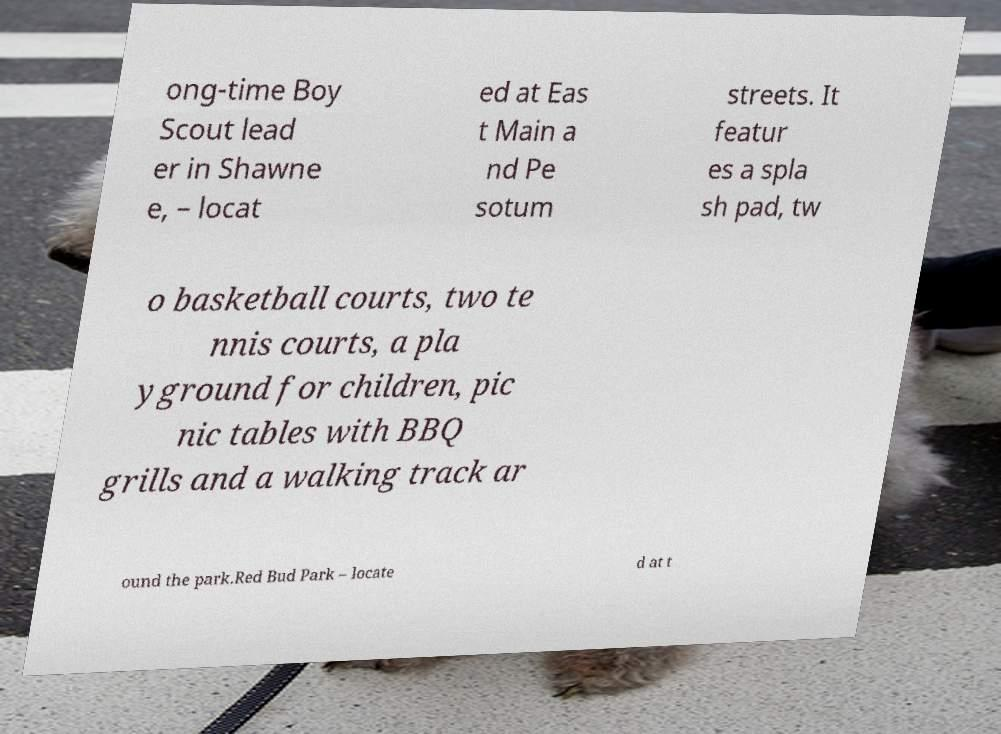Could you extract and type out the text from this image? ong-time Boy Scout lead er in Shawne e, – locat ed at Eas t Main a nd Pe sotum streets. It featur es a spla sh pad, tw o basketball courts, two te nnis courts, a pla yground for children, pic nic tables with BBQ grills and a walking track ar ound the park.Red Bud Park – locate d at t 